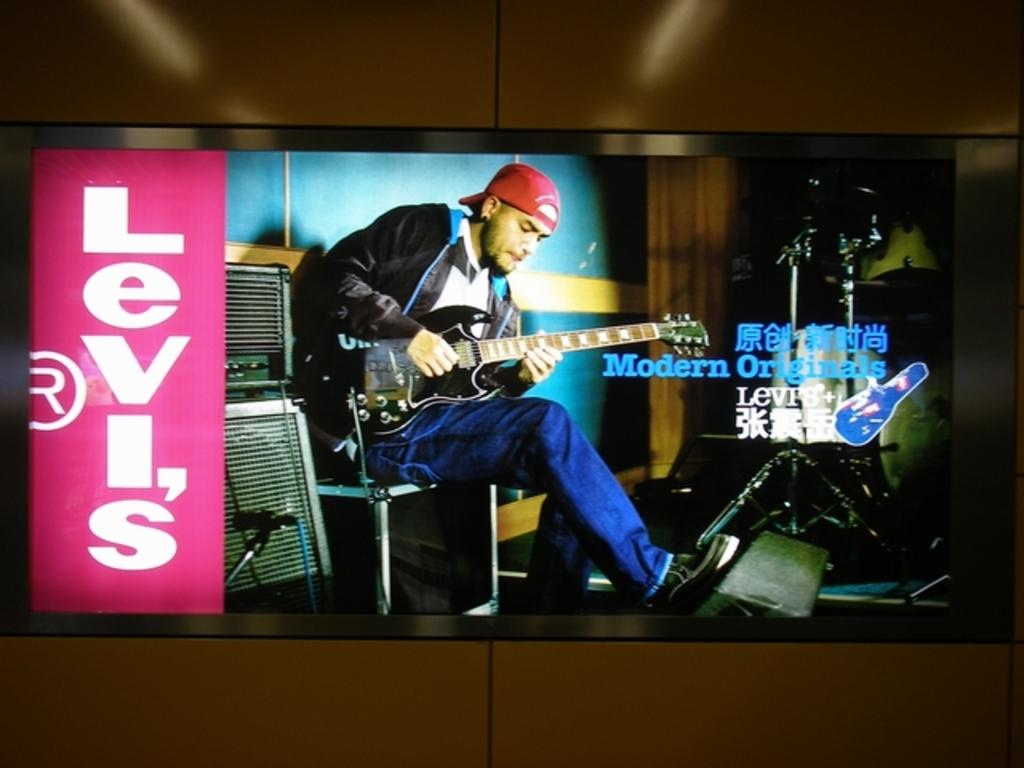<image>
Give a short and clear explanation of the subsequent image. the word Levi's which is next to a man 